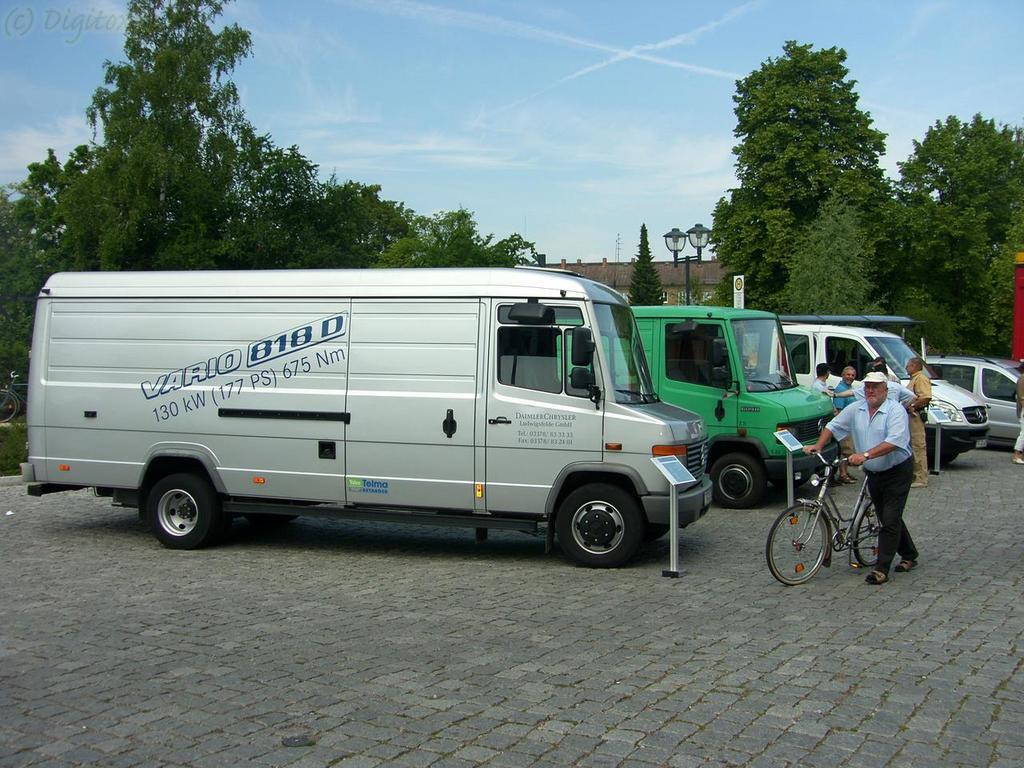What types of objects are present in the image? There are vehicles, persons, trees, a building, and poles in the image. Can you describe the actions of the persons in the image? There is a man holding a bicycle and walking in the image. What is the weather like in the image? The sky is cloudy in the image. What type of juice is being squeezed from the nerve in the image? There is no juice or nerve present in the image; it features vehicles, persons, trees, a building, and poles. How many people are joining the man holding the bicycle in the image? There is no indication in the image that anyone is joining the man holding the bicycle, as he is walking alone. 